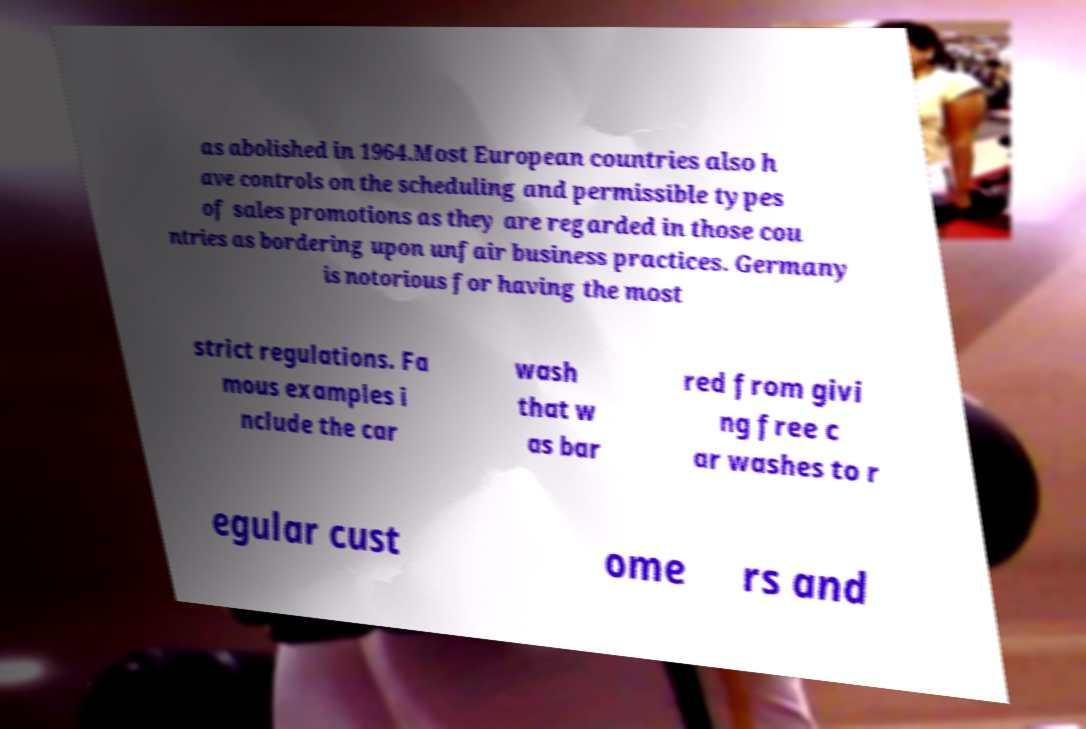Please read and relay the text visible in this image. What does it say? as abolished in 1964.Most European countries also h ave controls on the scheduling and permissible types of sales promotions as they are regarded in those cou ntries as bordering upon unfair business practices. Germany is notorious for having the most strict regulations. Fa mous examples i nclude the car wash that w as bar red from givi ng free c ar washes to r egular cust ome rs and 